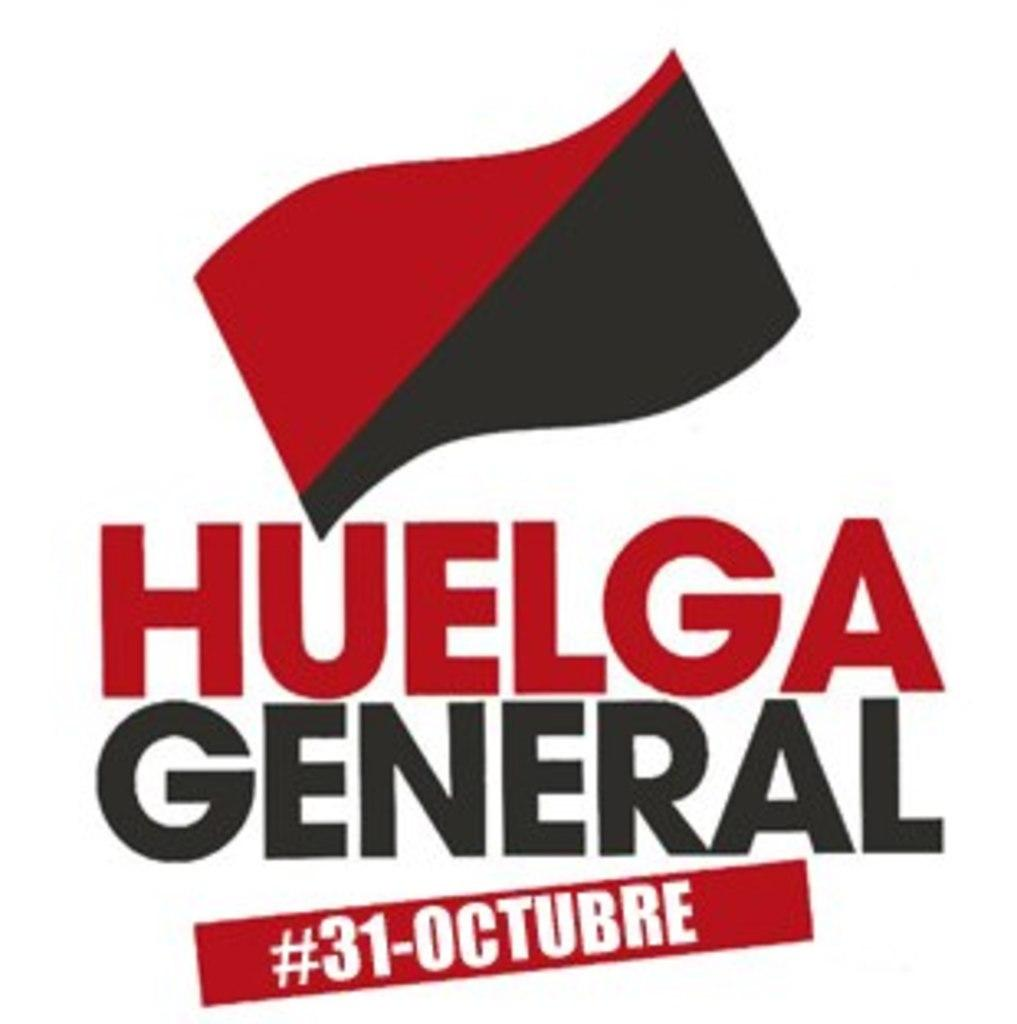<image>
Present a compact description of the photo's key features. a red and black flag are on a poster for huelga general 